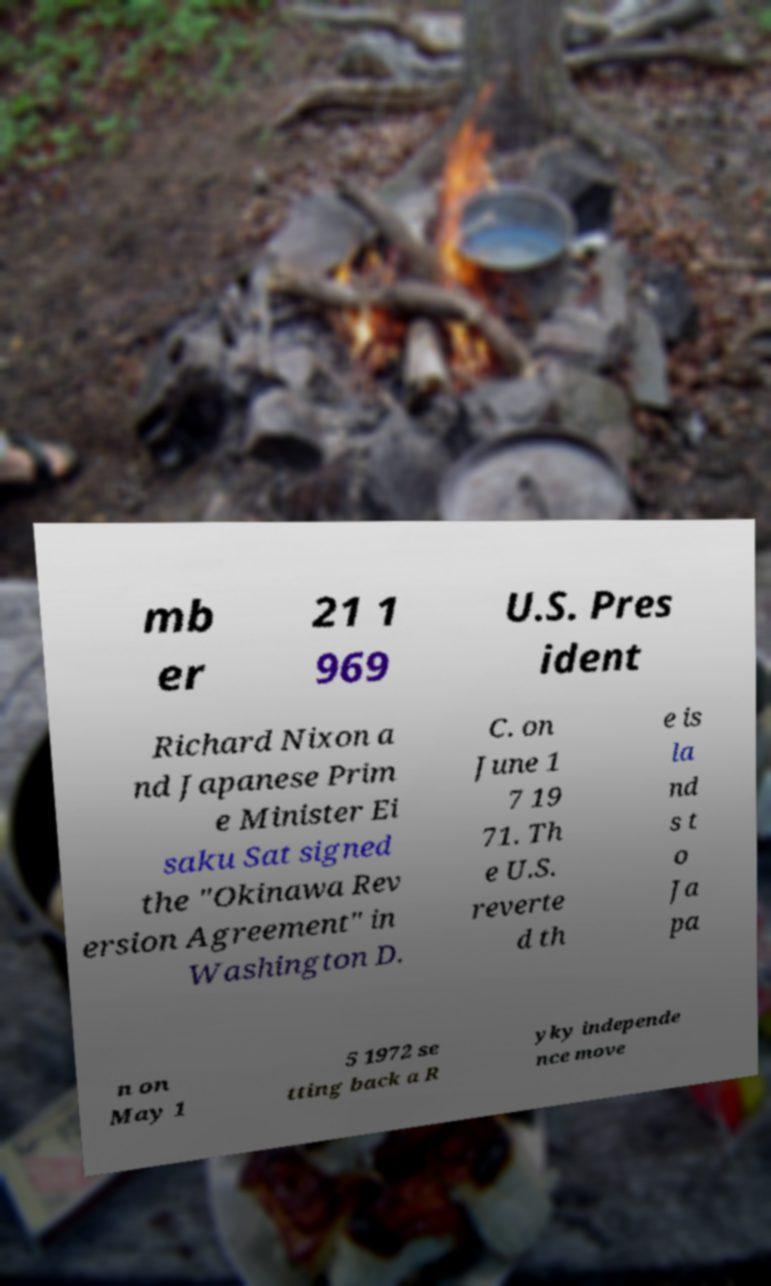Please identify and transcribe the text found in this image. mb er 21 1 969 U.S. Pres ident Richard Nixon a nd Japanese Prim e Minister Ei saku Sat signed the "Okinawa Rev ersion Agreement" in Washington D. C. on June 1 7 19 71. Th e U.S. reverte d th e is la nd s t o Ja pa n on May 1 5 1972 se tting back a R yky independe nce move 